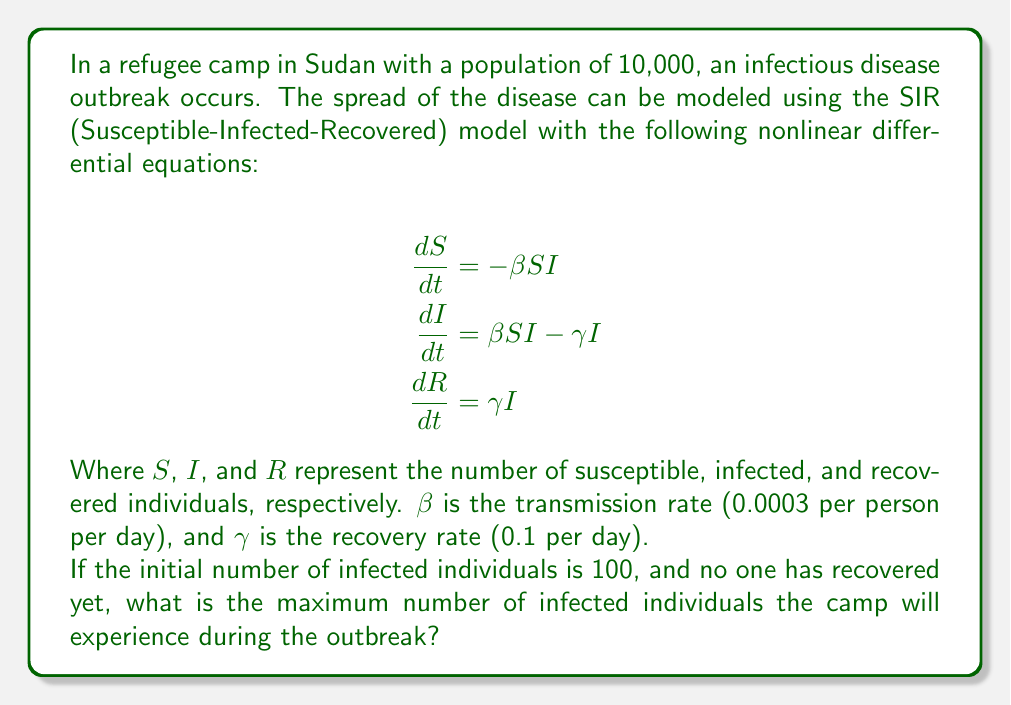Show me your answer to this math problem. To solve this problem, we need to follow these steps:

1) First, we need to find the initial conditions:
   $S(0) = 9900$ (10,000 - 100 infected)
   $I(0) = 100$
   $R(0) = 0$

2) The maximum number of infected individuals occurs when $\frac{dI}{dt} = 0$. At this point:

   $$\beta SI - \gamma I = 0$$

3) Solving for $S$:

   $$\beta S = \gamma$$
   $$S = \frac{\gamma}{\beta} = \frac{0.1}{0.0003} = 333.33$$

4) This means that when there are 333.33 susceptible individuals, the number of infected will be at its peak.

5) We can use the conservation of population to find the maximum number of infected:

   $$N = S + I + R = 10,000$$

   At the peak: $333.33 + I_{max} + R = 10,000$

6) To find $R$, we can use the ratio of $S$ to $R$ from the SIR model:

   $$\frac{S}{S_0} = e^{-\frac{R}{N}\cdot\frac{\gamma}{\beta}}$$

   $$\frac{333.33}{9900} = e^{-\frac{R}{10000}\cdot\frac{0.1}{0.0003}}$$

7) Solving this numerically (as it's transcendental), we get:

   $R \approx 6,633$

8) Now we can solve for $I_{max}$:

   $333.33 + I_{max} + 6,633 = 10,000$
   $I_{max} = 10,000 - 333.33 - 6,633 = 3,033.67$

Therefore, the maximum number of infected individuals, rounded to the nearest whole number, is 3,034.
Answer: 3,034 